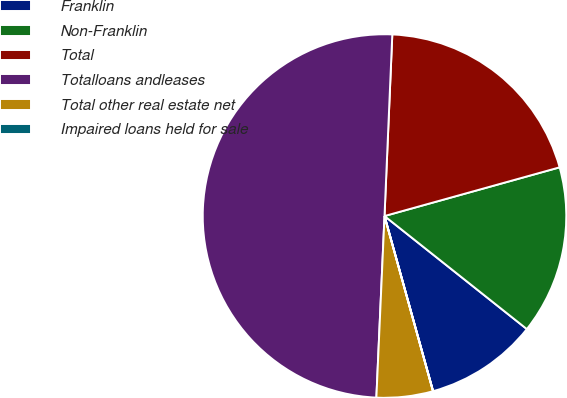Convert chart to OTSL. <chart><loc_0><loc_0><loc_500><loc_500><pie_chart><fcel>Franklin<fcel>Non-Franklin<fcel>Total<fcel>Totalloans andleases<fcel>Total other real estate net<fcel>Impaired loans held for sale<nl><fcel>10.01%<fcel>15.0%<fcel>20.0%<fcel>49.97%<fcel>5.01%<fcel>0.01%<nl></chart> 